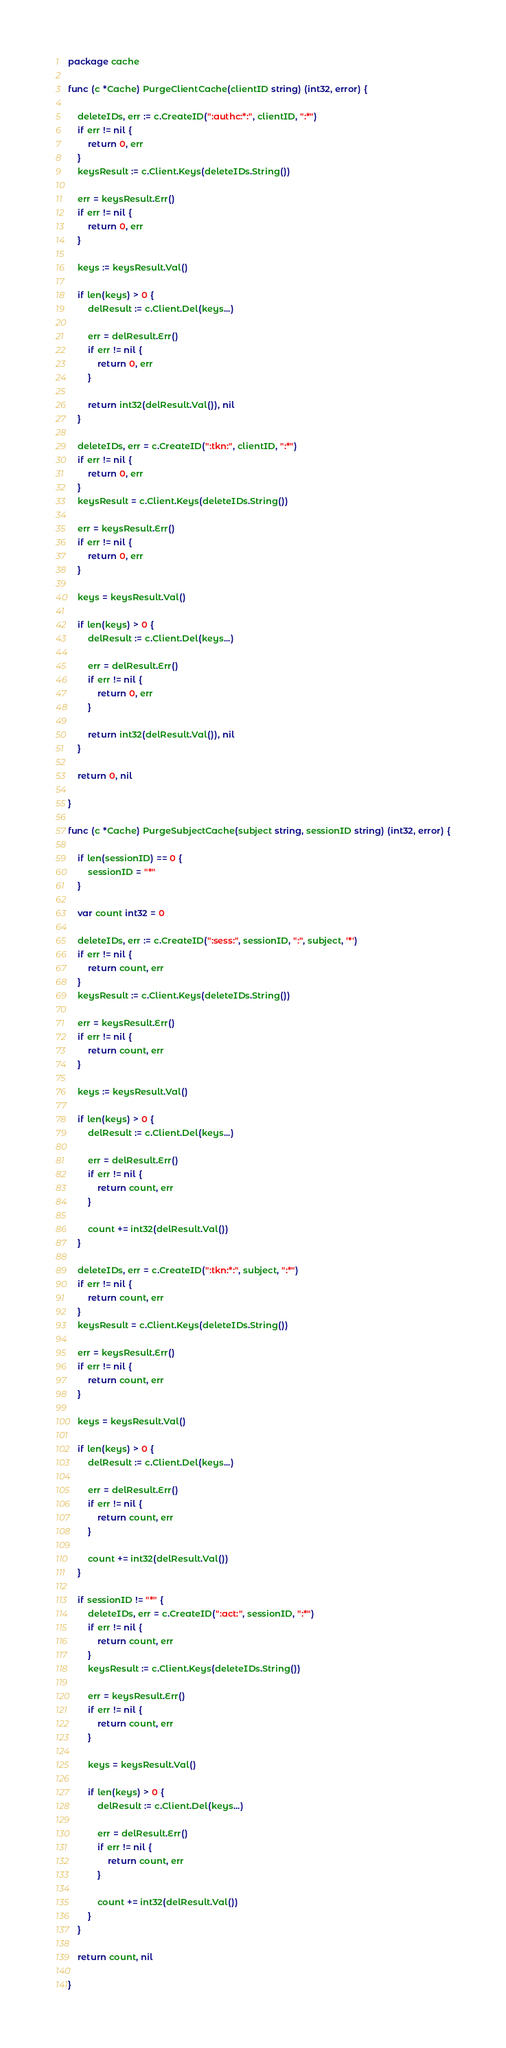Convert code to text. <code><loc_0><loc_0><loc_500><loc_500><_Go_>package cache

func (c *Cache) PurgeClientCache(clientID string) (int32, error) {

	deleteIDs, err := c.CreateID(":authc:*:", clientID, ":*")
	if err != nil {
		return 0, err
	}
	keysResult := c.Client.Keys(deleteIDs.String())

	err = keysResult.Err()
	if err != nil {
		return 0, err
	}

	keys := keysResult.Val()

	if len(keys) > 0 {
		delResult := c.Client.Del(keys...)

		err = delResult.Err()
		if err != nil {
			return 0, err
		}

		return int32(delResult.Val()), nil
	}

	deleteIDs, err = c.CreateID(":tkn:", clientID, ":*")
	if err != nil {
		return 0, err
	}
	keysResult = c.Client.Keys(deleteIDs.String())

	err = keysResult.Err()
	if err != nil {
		return 0, err
	}

	keys = keysResult.Val()

	if len(keys) > 0 {
		delResult := c.Client.Del(keys...)

		err = delResult.Err()
		if err != nil {
			return 0, err
		}

		return int32(delResult.Val()), nil
	}

	return 0, nil

}

func (c *Cache) PurgeSubjectCache(subject string, sessionID string) (int32, error) {

	if len(sessionID) == 0 {
		sessionID = "*"
	}

	var count int32 = 0

	deleteIDs, err := c.CreateID(":sess:", sessionID, ":", subject, '*')
	if err != nil {
		return count, err
	}
	keysResult := c.Client.Keys(deleteIDs.String())

	err = keysResult.Err()
	if err != nil {
		return count, err
	}

	keys := keysResult.Val()

	if len(keys) > 0 {
		delResult := c.Client.Del(keys...)

		err = delResult.Err()
		if err != nil {
			return count, err
		}

		count += int32(delResult.Val())
	}

	deleteIDs, err = c.CreateID(":tkn:*:", subject, ":*")
	if err != nil {
		return count, err
	}
	keysResult = c.Client.Keys(deleteIDs.String())

	err = keysResult.Err()
	if err != nil {
		return count, err
	}

	keys = keysResult.Val()

	if len(keys) > 0 {
		delResult := c.Client.Del(keys...)

		err = delResult.Err()
		if err != nil {
			return count, err
		}

		count += int32(delResult.Val())
	}

	if sessionID != "*" {
		deleteIDs, err = c.CreateID(":act:", sessionID, ":*")
		if err != nil {
			return count, err
		}
		keysResult := c.Client.Keys(deleteIDs.String())

		err = keysResult.Err()
		if err != nil {
			return count, err
		}

		keys = keysResult.Val()

		if len(keys) > 0 {
			delResult := c.Client.Del(keys...)

			err = delResult.Err()
			if err != nil {
				return count, err
			}

			count += int32(delResult.Val())
		}
	}

	return count, nil

}
</code> 